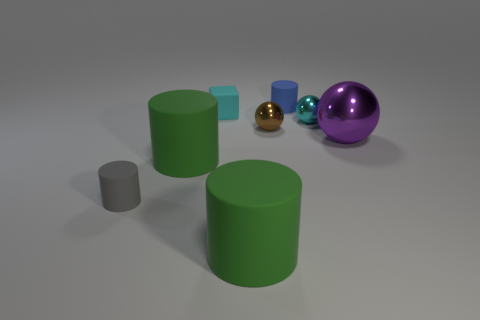Are there any other things that are the same material as the tiny gray thing?
Offer a terse response. Yes. Is there a cyan ball made of the same material as the brown sphere?
Your answer should be compact. Yes. There is a cyan ball that is the same size as the brown shiny sphere; what is it made of?
Offer a very short reply. Metal. Is the material of the blue cylinder the same as the brown object?
Ensure brevity in your answer.  No. What number of objects are large matte things or small metal cylinders?
Your response must be concise. 2. What shape is the big green object that is to the right of the tiny cube?
Your answer should be compact. Cylinder. There is a tiny thing that is made of the same material as the brown sphere; what color is it?
Keep it short and to the point. Cyan. There is a gray thing that is the same shape as the blue matte object; what is it made of?
Ensure brevity in your answer.  Rubber. What is the shape of the small cyan matte object?
Keep it short and to the point. Cube. There is a cylinder that is both behind the gray matte cylinder and in front of the blue rubber cylinder; what material is it made of?
Provide a succinct answer. Rubber. 